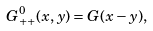<formula> <loc_0><loc_0><loc_500><loc_500>G _ { + + } ^ { 0 } ( x , y ) = G ( x - y ) ,</formula> 